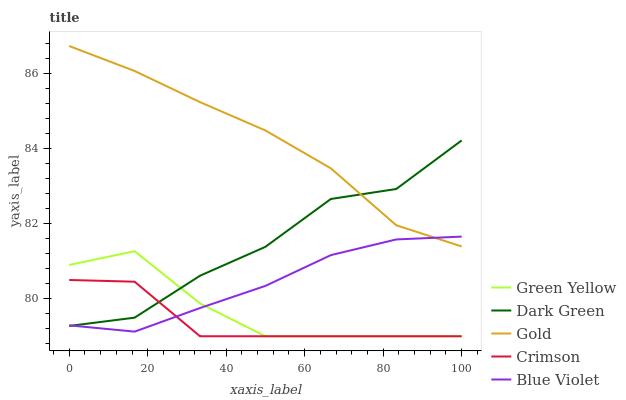Does Crimson have the minimum area under the curve?
Answer yes or no. Yes. Does Gold have the maximum area under the curve?
Answer yes or no. Yes. Does Green Yellow have the minimum area under the curve?
Answer yes or no. No. Does Green Yellow have the maximum area under the curve?
Answer yes or no. No. Is Blue Violet the smoothest?
Answer yes or no. Yes. Is Dark Green the roughest?
Answer yes or no. Yes. Is Green Yellow the smoothest?
Answer yes or no. No. Is Green Yellow the roughest?
Answer yes or no. No. Does Crimson have the lowest value?
Answer yes or no. Yes. Does Blue Violet have the lowest value?
Answer yes or no. No. Does Gold have the highest value?
Answer yes or no. Yes. Does Green Yellow have the highest value?
Answer yes or no. No. Is Green Yellow less than Gold?
Answer yes or no. Yes. Is Gold greater than Crimson?
Answer yes or no. Yes. Does Dark Green intersect Gold?
Answer yes or no. Yes. Is Dark Green less than Gold?
Answer yes or no. No. Is Dark Green greater than Gold?
Answer yes or no. No. Does Green Yellow intersect Gold?
Answer yes or no. No. 